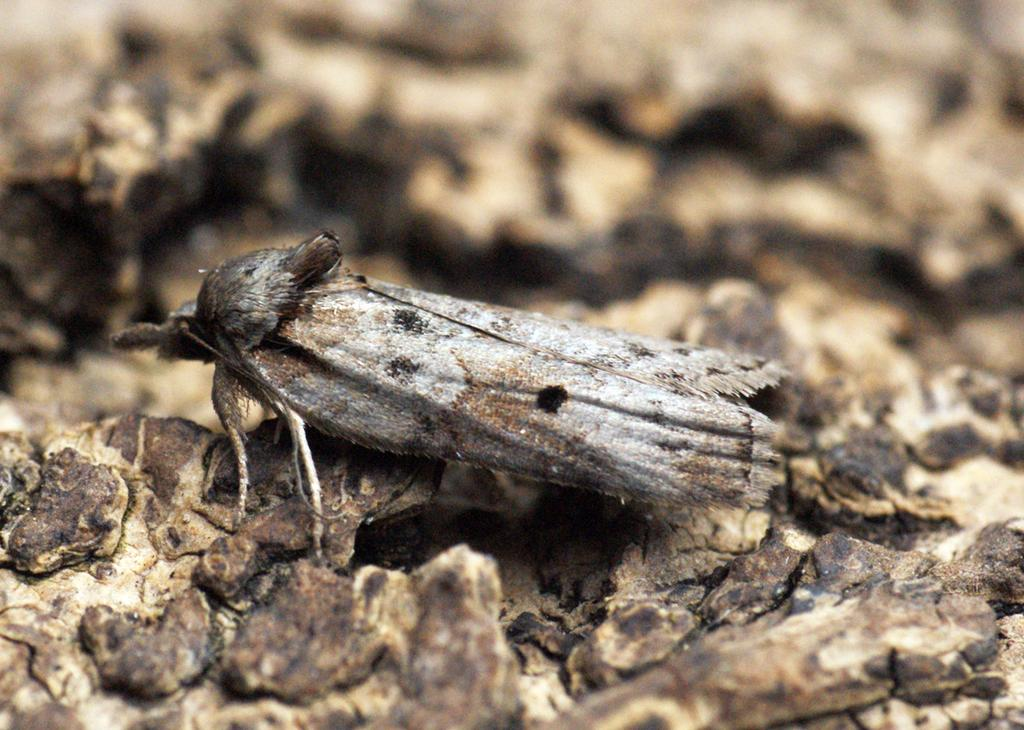What type of creature can be seen in the image? There is an insect in the image. Where is the insect located? The insect is on tree bark. What type of bed can be seen in the image? There is no bed present in the image; it features an insect on tree bark. Can you tell me how many lakes are visible in the image? There are no lakes visible in the image; it features an insect on tree bark. 